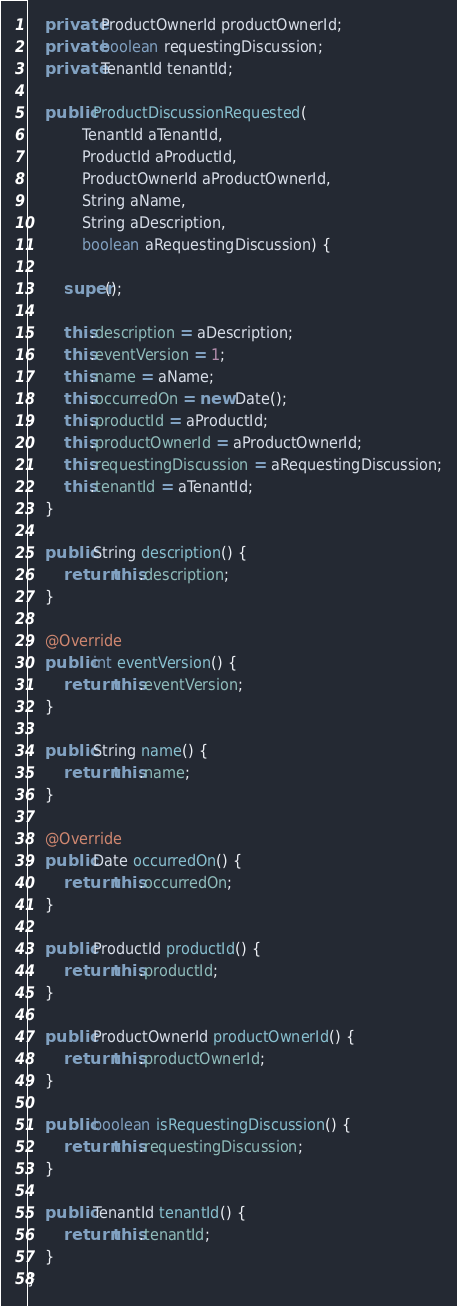Convert code to text. <code><loc_0><loc_0><loc_500><loc_500><_Java_>    private ProductOwnerId productOwnerId;
    private boolean requestingDiscussion;
    private TenantId tenantId;

    public ProductDiscussionRequested(
            TenantId aTenantId,
            ProductId aProductId,
            ProductOwnerId aProductOwnerId,
            String aName,
            String aDescription,
            boolean aRequestingDiscussion) {

        super();

        this.description = aDescription;
        this.eventVersion = 1;
        this.name = aName;
        this.occurredOn = new Date();
        this.productId = aProductId;
        this.productOwnerId = aProductOwnerId;
        this.requestingDiscussion = aRequestingDiscussion;
        this.tenantId = aTenantId;
    }

    public String description() {
        return this.description;
    }

    @Override
    public int eventVersion() {
        return this.eventVersion;
    }

    public String name() {
        return this.name;
    }

    @Override
    public Date occurredOn() {
        return this.occurredOn;
    }

    public ProductId productId() {
        return this.productId;
    }

    public ProductOwnerId productOwnerId() {
        return this.productOwnerId;
    }

    public boolean isRequestingDiscussion() {
        return this.requestingDiscussion;
    }

    public TenantId tenantId() {
        return this.tenantId;
    }
}
</code> 